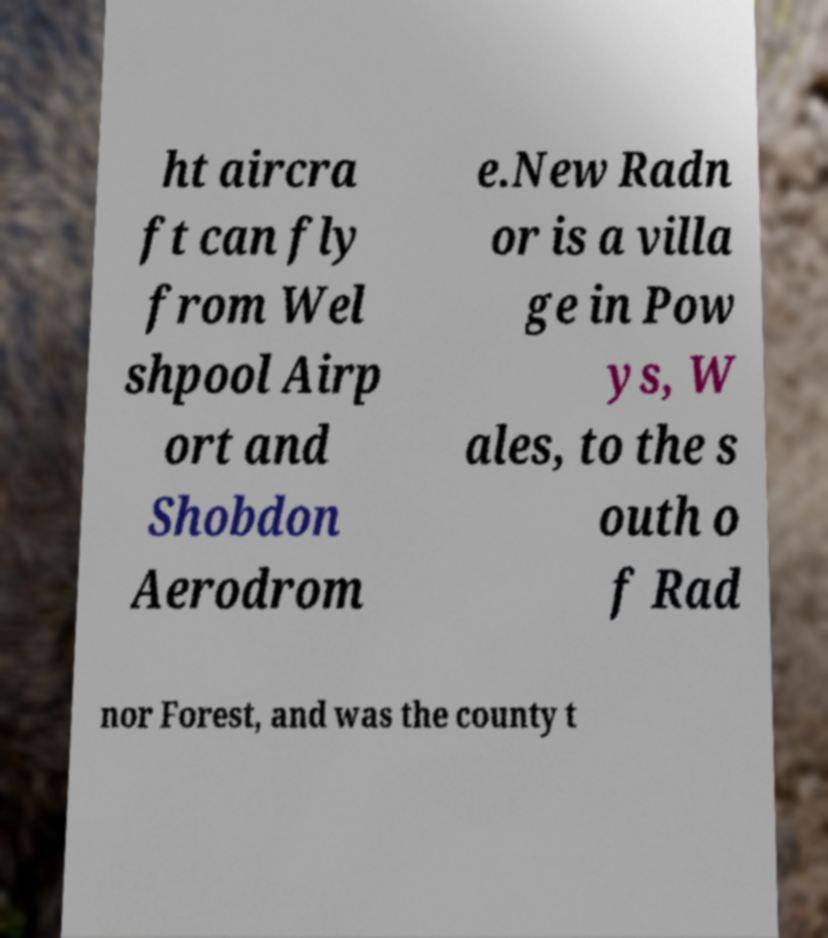I need the written content from this picture converted into text. Can you do that? ht aircra ft can fly from Wel shpool Airp ort and Shobdon Aerodrom e.New Radn or is a villa ge in Pow ys, W ales, to the s outh o f Rad nor Forest, and was the county t 